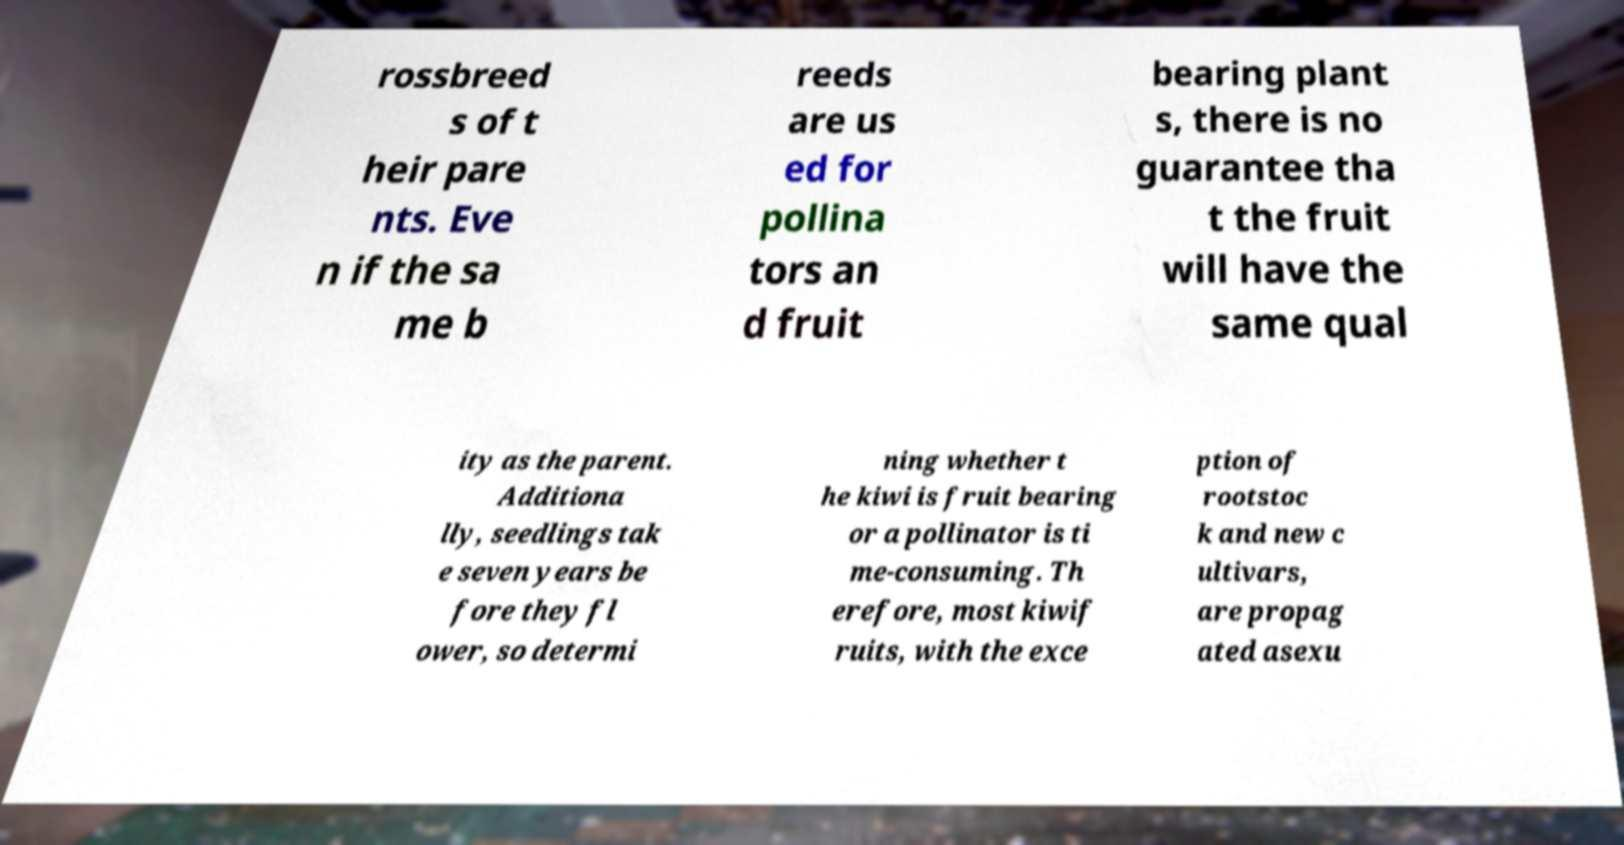What messages or text are displayed in this image? I need them in a readable, typed format. rossbreed s of t heir pare nts. Eve n if the sa me b reeds are us ed for pollina tors an d fruit bearing plant s, there is no guarantee tha t the fruit will have the same qual ity as the parent. Additiona lly, seedlings tak e seven years be fore they fl ower, so determi ning whether t he kiwi is fruit bearing or a pollinator is ti me-consuming. Th erefore, most kiwif ruits, with the exce ption of rootstoc k and new c ultivars, are propag ated asexu 